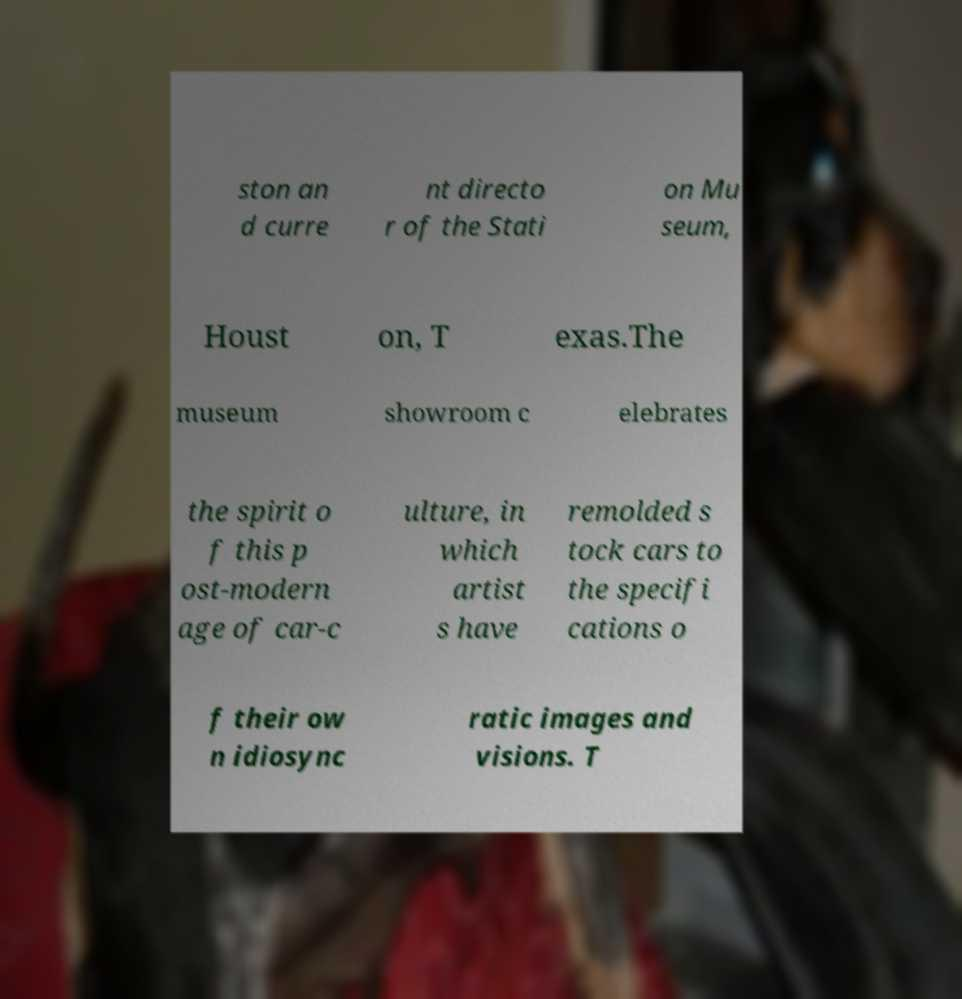There's text embedded in this image that I need extracted. Can you transcribe it verbatim? ston an d curre nt directo r of the Stati on Mu seum, Houst on, T exas.The museum showroom c elebrates the spirit o f this p ost-modern age of car-c ulture, in which artist s have remolded s tock cars to the specifi cations o f their ow n idiosync ratic images and visions. T 